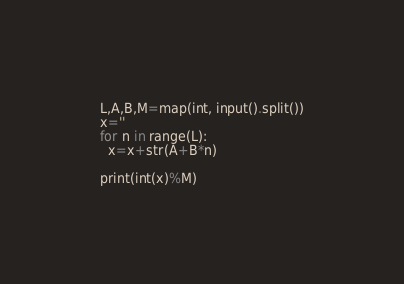Convert code to text. <code><loc_0><loc_0><loc_500><loc_500><_Python_>L,A,B,M=map(int, input().split())
x=''
for n in range(L):
  x=x+str(A+B*n)

print(int(x)%M)</code> 